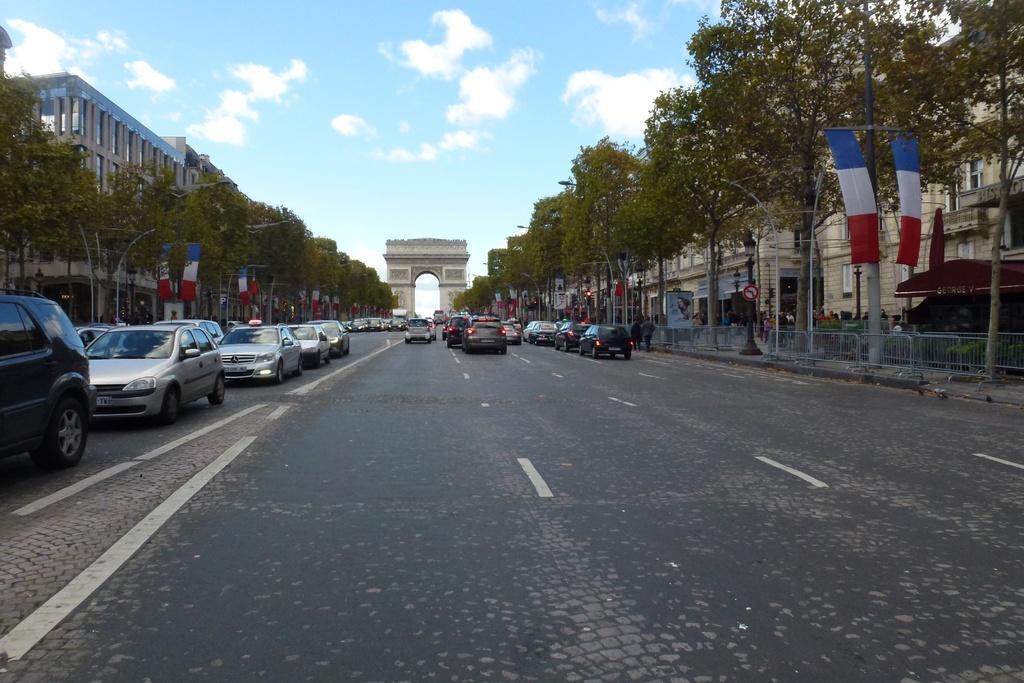In one or two sentences, can you explain what this image depicts? In this picture we can see cars on the road, trees, flags, fences, buildings, poles, posters, arch and a group of people and some objects and in the background we can see the sky with clouds. 